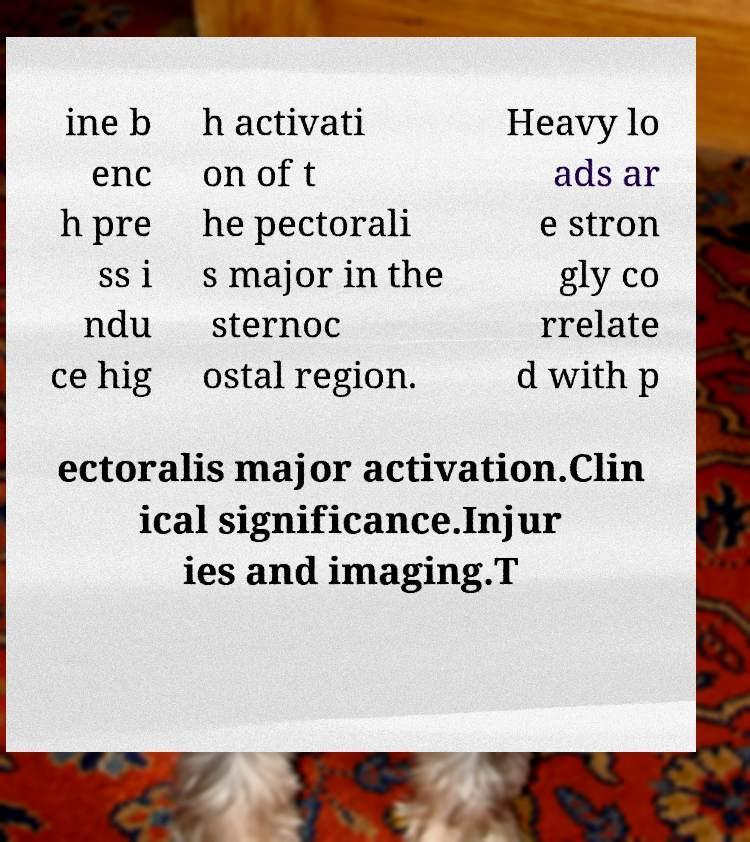Can you read and provide the text displayed in the image?This photo seems to have some interesting text. Can you extract and type it out for me? ine b enc h pre ss i ndu ce hig h activati on of t he pectorali s major in the sternoc ostal region. Heavy lo ads ar e stron gly co rrelate d with p ectoralis major activation.Clin ical significance.Injur ies and imaging.T 